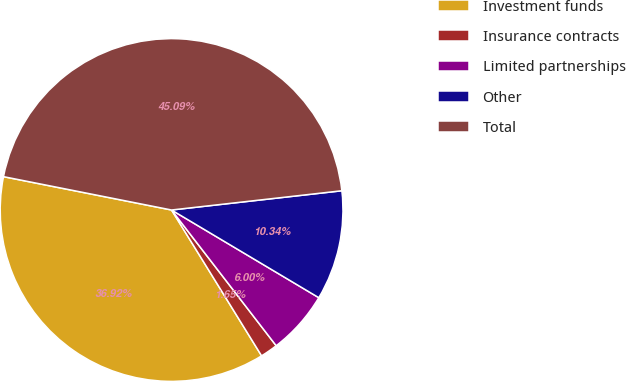Convert chart. <chart><loc_0><loc_0><loc_500><loc_500><pie_chart><fcel>Investment funds<fcel>Insurance contracts<fcel>Limited partnerships<fcel>Other<fcel>Total<nl><fcel>36.92%<fcel>1.65%<fcel>6.0%<fcel>10.34%<fcel>45.09%<nl></chart> 